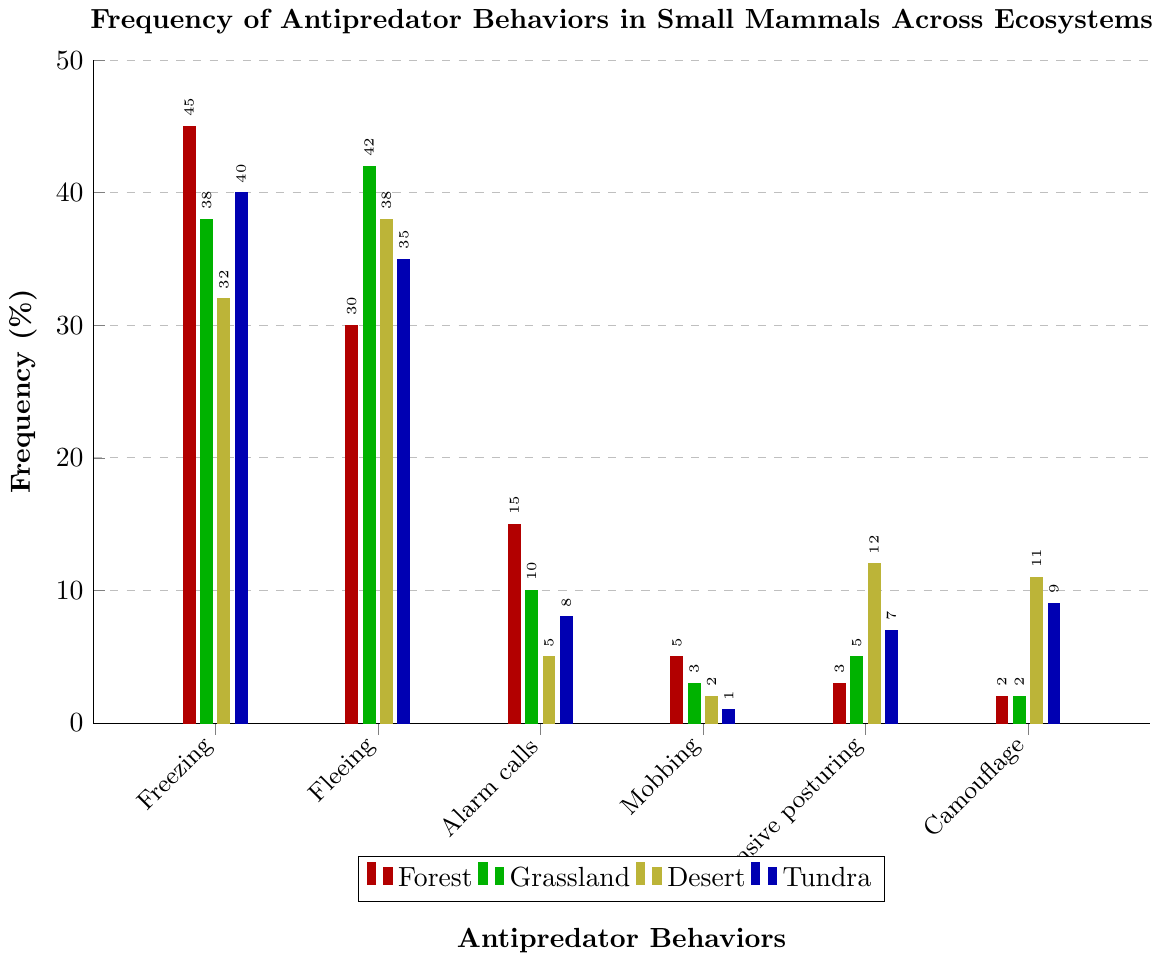What is the most frequently used antipredator behavior in the forest ecosystem? To determine the most frequently used behavior in the forest ecosystem, look at the bar heights for the "Forest" category for each behavior. The highest frequency is associated with "Freezing" at 45%.
Answer: Freezing Which ecosystem has the highest frequency of camouflage behavior? For each ecosystem, compare the bar heights under "Camouflage". The highest bar is for the Desert ecosystem at 11%.
Answer: Desert Calculate the average frequency of fleeing behavior across all ecosystems. Add the frequency values for "Fleeing" across Forest, Grassland, Desert, and Tundra: 30, 42, 38, and 35. Sum = 145. Divide by the number of ecosystems (4): 145 / 4 = 36.25
Answer: 36.25 Which antipredator behavior has the lowest frequency in the grassland ecosystem? Look at all the bars in the "Grassland" category and identify the shortest one. The shortest bar corresponds to "Camouflage" and "Mobbing" at 2% and 3%, with “Mobbing” being slightly taller, so "Camouflage" is the lowest.
Answer: Camouflage What is the difference in frequency of defensive posturing behavior between the desert and tundra ecosystems? Identify the bars corresponding to "Defensive posturing" in the Desert and Tundra ecosystems, which are 12% and 7%, respectively. The difference is 12 - 7 = 5.
Answer: 5 Order the ecosystems by the frequency of alarm calls behavior in descending order. Find the frequency values for "Alarm calls" in each ecosystem: Forest (15%), Grassland (10%), Desert (5%), Tundra (8%). Arrange them from highest to lowest: Forest (15%), Grassland (10%), Tundra (8%), Desert (5%).
Answer: Forest, Grassland, Tundra, Desert Which behavior has a higher frequency in tundra compared to grassland, but a lower frequency in desert compared to forest? Compare bars for "Grassland" and "Tundra", and "Forest" and "Desert" for each behavior. "Camouflage" is higher in Tundra (9%) compared to Grassland (2%), but lower in Desert (11%) compared to Forest (2%).
Answer: Camouflage If the frequency of each behavior in tundra were doubled, which behavior would have the highest frequency? Double the frequencies for Tundra: Freezing (40x2=80), Fleeing (35x2=70), Alarm calls (8x2=16), Mobbing (1x2=2), Defensive posturing (7x2=14), Camouflage (9x2=18). The highest value is for "Freezing" at 80%.
Answer: Freezing 